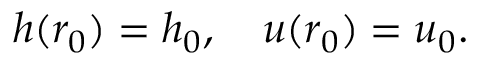<formula> <loc_0><loc_0><loc_500><loc_500>h ( r _ { 0 } ) = h _ { 0 } , \quad u ( r _ { 0 } ) = u _ { 0 } .</formula> 